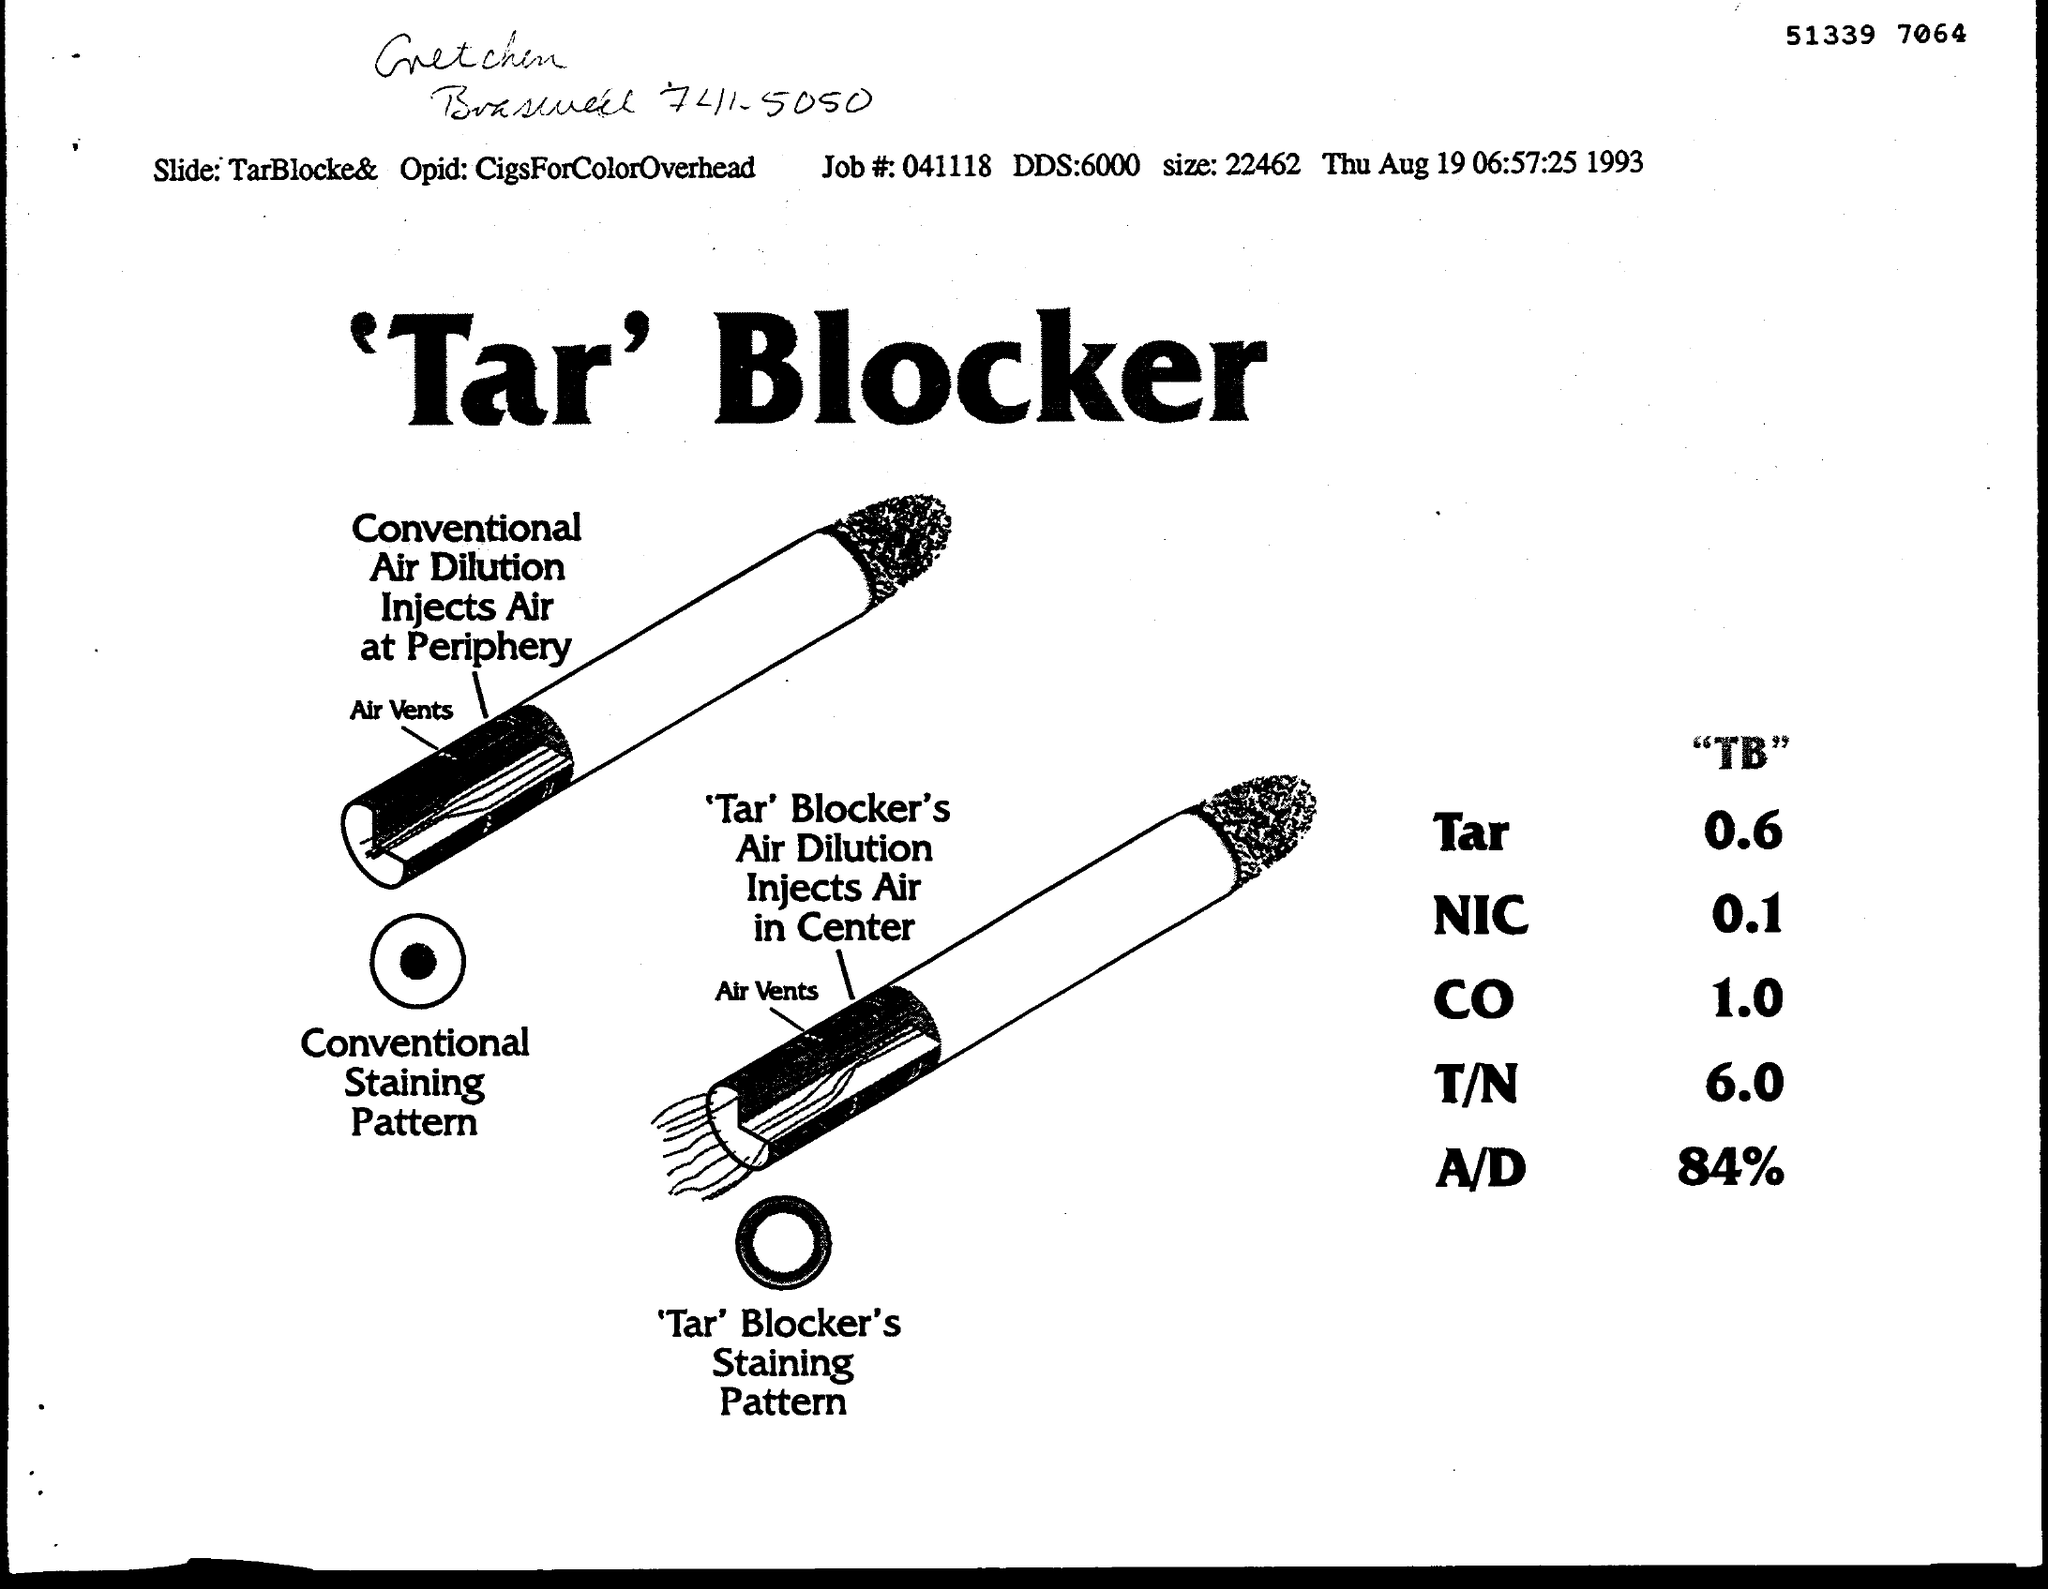Draw attention to some important aspects in this diagram. The date on the document is August 19th. The job number is 041118... The Opid is a unique identifier assigned to each cigarette pack sold in the country, which is used to track and monitor cigarette sales. The CigsForColorOverhead variable contains the overhead costs associated with producing cigarettes in different colors, and is used to calculate the price of cigarettes in each color. The size is 22462... What is the Slide? TarBlocke&TarBlocKeeper. 